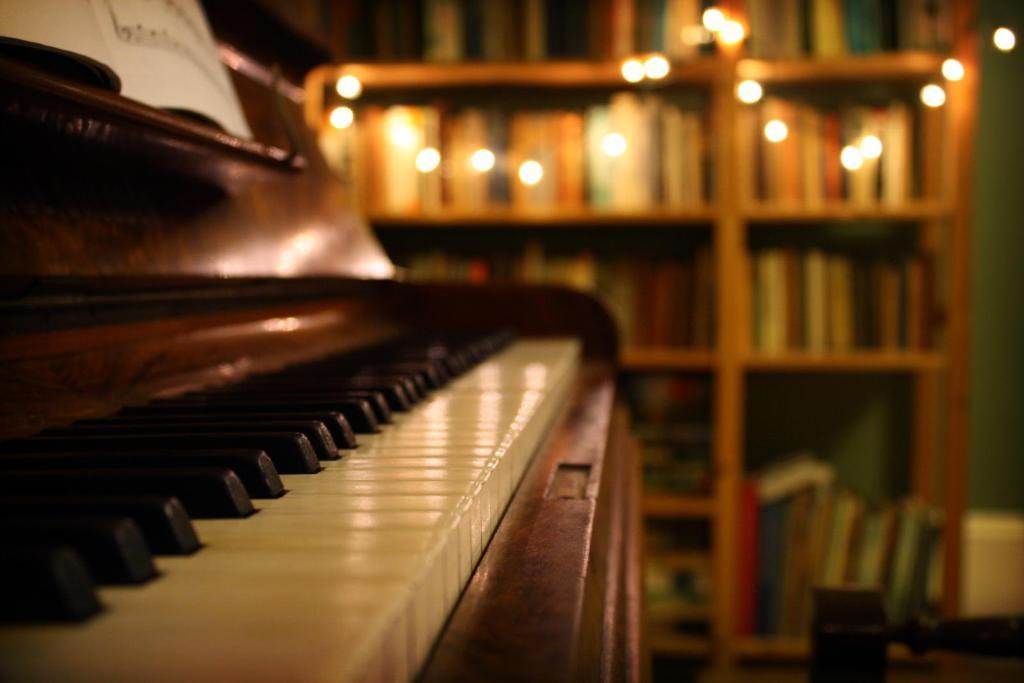What object in the image is used for creating music? There is a musical instrument in the image. What can be seen in the background of the image that is used for decoration? There are lights as decoration in the background of the image. What type of yam is being used as a prop in the image? There is no yam present in the image. What type of test is being conducted in the image? There is no test being conducted in the image. 